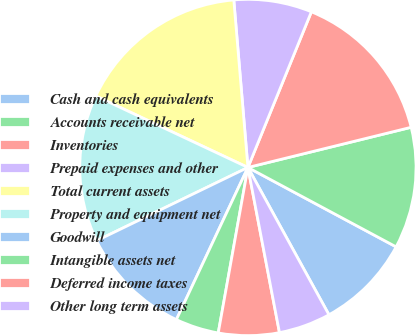<chart> <loc_0><loc_0><loc_500><loc_500><pie_chart><fcel>Cash and cash equivalents<fcel>Accounts receivable net<fcel>Inventories<fcel>Prepaid expenses and other<fcel>Total current assets<fcel>Property and equipment net<fcel>Goodwill<fcel>Intangible assets net<fcel>Deferred income taxes<fcel>Other long term assets<nl><fcel>9.17%<fcel>11.67%<fcel>15.0%<fcel>7.5%<fcel>16.67%<fcel>14.17%<fcel>10.83%<fcel>4.17%<fcel>5.83%<fcel>5.0%<nl></chart> 